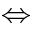Convert formula to latex. <formula><loc_0><loc_0><loc_500><loc_500>\Leftrightarrow</formula> 